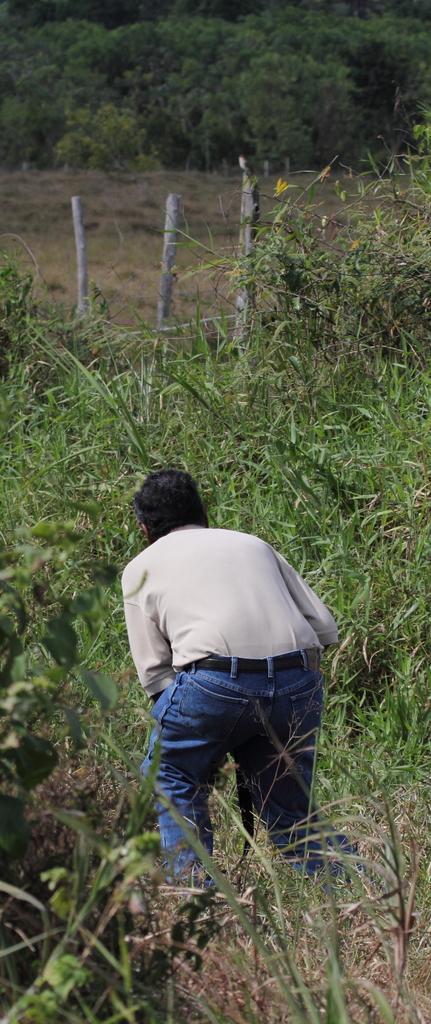Describe this image in one or two sentences. In the image there is a lot of grass and there is a person in between the grass, in the background there are many trees. 